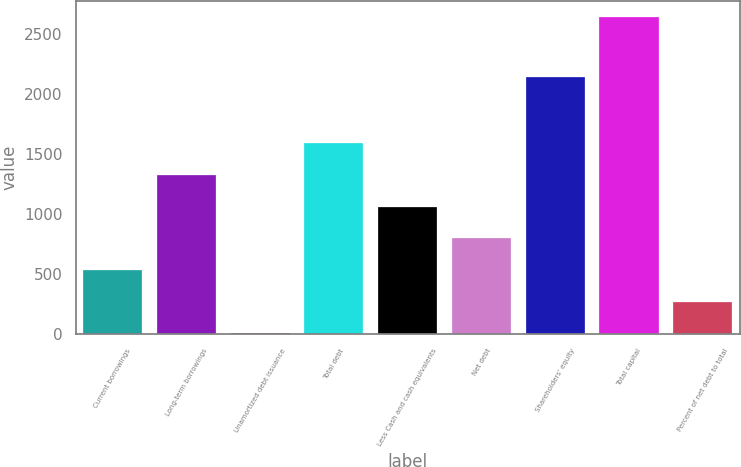Convert chart to OTSL. <chart><loc_0><loc_0><loc_500><loc_500><bar_chart><fcel>Current borrowings<fcel>Long-term borrowings<fcel>Unamortized debt issuance<fcel>Total debt<fcel>Less Cash and cash equivalents<fcel>Net debt<fcel>Shareholders' equity<fcel>Total capital<fcel>Percent of net debt to total<nl><fcel>535.96<fcel>1324.9<fcel>10<fcel>1587.88<fcel>1061.92<fcel>798.94<fcel>2137.5<fcel>2639.8<fcel>272.98<nl></chart> 